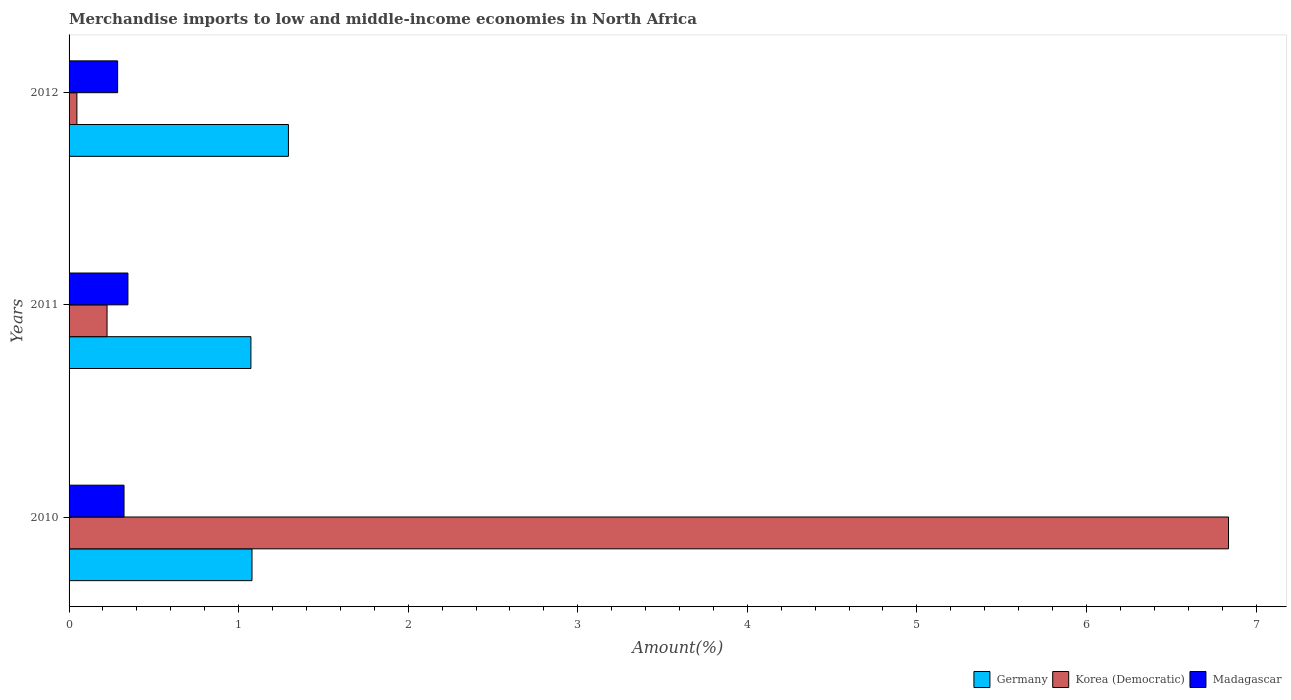How many different coloured bars are there?
Your answer should be very brief. 3. How many groups of bars are there?
Give a very brief answer. 3. How many bars are there on the 2nd tick from the top?
Your answer should be compact. 3. How many bars are there on the 2nd tick from the bottom?
Your answer should be very brief. 3. What is the label of the 1st group of bars from the top?
Offer a very short reply. 2012. What is the percentage of amount earned from merchandise imports in Korea (Democratic) in 2010?
Make the answer very short. 6.84. Across all years, what is the maximum percentage of amount earned from merchandise imports in Madagascar?
Provide a short and direct response. 0.35. Across all years, what is the minimum percentage of amount earned from merchandise imports in Korea (Democratic)?
Keep it short and to the point. 0.05. In which year was the percentage of amount earned from merchandise imports in Korea (Democratic) minimum?
Provide a succinct answer. 2012. What is the total percentage of amount earned from merchandise imports in Germany in the graph?
Your answer should be compact. 3.44. What is the difference between the percentage of amount earned from merchandise imports in Madagascar in 2010 and that in 2012?
Ensure brevity in your answer.  0.04. What is the difference between the percentage of amount earned from merchandise imports in Korea (Democratic) in 2010 and the percentage of amount earned from merchandise imports in Germany in 2012?
Your answer should be compact. 5.54. What is the average percentage of amount earned from merchandise imports in Korea (Democratic) per year?
Make the answer very short. 2.37. In the year 2011, what is the difference between the percentage of amount earned from merchandise imports in Germany and percentage of amount earned from merchandise imports in Korea (Democratic)?
Ensure brevity in your answer.  0.85. In how many years, is the percentage of amount earned from merchandise imports in Germany greater than 4.6 %?
Give a very brief answer. 0. What is the ratio of the percentage of amount earned from merchandise imports in Korea (Democratic) in 2011 to that in 2012?
Offer a very short reply. 4.86. Is the percentage of amount earned from merchandise imports in Korea (Democratic) in 2011 less than that in 2012?
Keep it short and to the point. No. Is the difference between the percentage of amount earned from merchandise imports in Germany in 2010 and 2011 greater than the difference between the percentage of amount earned from merchandise imports in Korea (Democratic) in 2010 and 2011?
Provide a short and direct response. No. What is the difference between the highest and the second highest percentage of amount earned from merchandise imports in Germany?
Provide a short and direct response. 0.21. What is the difference between the highest and the lowest percentage of amount earned from merchandise imports in Korea (Democratic)?
Keep it short and to the point. 6.79. In how many years, is the percentage of amount earned from merchandise imports in Korea (Democratic) greater than the average percentage of amount earned from merchandise imports in Korea (Democratic) taken over all years?
Provide a succinct answer. 1. What does the 2nd bar from the top in 2011 represents?
Offer a terse response. Korea (Democratic). What does the 2nd bar from the bottom in 2012 represents?
Offer a terse response. Korea (Democratic). Is it the case that in every year, the sum of the percentage of amount earned from merchandise imports in Korea (Democratic) and percentage of amount earned from merchandise imports in Madagascar is greater than the percentage of amount earned from merchandise imports in Germany?
Provide a succinct answer. No. What is the difference between two consecutive major ticks on the X-axis?
Offer a very short reply. 1. Are the values on the major ticks of X-axis written in scientific E-notation?
Your answer should be compact. No. How are the legend labels stacked?
Your answer should be compact. Horizontal. What is the title of the graph?
Your answer should be very brief. Merchandise imports to low and middle-income economies in North Africa. Does "Samoa" appear as one of the legend labels in the graph?
Offer a terse response. No. What is the label or title of the X-axis?
Give a very brief answer. Amount(%). What is the Amount(%) of Germany in 2010?
Provide a short and direct response. 1.08. What is the Amount(%) of Korea (Democratic) in 2010?
Ensure brevity in your answer.  6.84. What is the Amount(%) of Madagascar in 2010?
Provide a short and direct response. 0.32. What is the Amount(%) in Germany in 2011?
Provide a succinct answer. 1.07. What is the Amount(%) of Korea (Democratic) in 2011?
Provide a short and direct response. 0.22. What is the Amount(%) of Madagascar in 2011?
Offer a very short reply. 0.35. What is the Amount(%) in Germany in 2012?
Your answer should be very brief. 1.29. What is the Amount(%) in Korea (Democratic) in 2012?
Keep it short and to the point. 0.05. What is the Amount(%) of Madagascar in 2012?
Give a very brief answer. 0.29. Across all years, what is the maximum Amount(%) of Germany?
Provide a succinct answer. 1.29. Across all years, what is the maximum Amount(%) of Korea (Democratic)?
Provide a succinct answer. 6.84. Across all years, what is the maximum Amount(%) in Madagascar?
Your answer should be compact. 0.35. Across all years, what is the minimum Amount(%) in Germany?
Make the answer very short. 1.07. Across all years, what is the minimum Amount(%) of Korea (Democratic)?
Keep it short and to the point. 0.05. Across all years, what is the minimum Amount(%) in Madagascar?
Make the answer very short. 0.29. What is the total Amount(%) in Germany in the graph?
Offer a terse response. 3.44. What is the total Amount(%) of Korea (Democratic) in the graph?
Provide a succinct answer. 7.11. What is the total Amount(%) in Madagascar in the graph?
Your answer should be very brief. 0.96. What is the difference between the Amount(%) of Germany in 2010 and that in 2011?
Offer a very short reply. 0.01. What is the difference between the Amount(%) in Korea (Democratic) in 2010 and that in 2011?
Keep it short and to the point. 6.61. What is the difference between the Amount(%) of Madagascar in 2010 and that in 2011?
Ensure brevity in your answer.  -0.02. What is the difference between the Amount(%) of Germany in 2010 and that in 2012?
Your answer should be compact. -0.21. What is the difference between the Amount(%) in Korea (Democratic) in 2010 and that in 2012?
Your response must be concise. 6.79. What is the difference between the Amount(%) in Madagascar in 2010 and that in 2012?
Offer a terse response. 0.04. What is the difference between the Amount(%) in Germany in 2011 and that in 2012?
Your answer should be very brief. -0.22. What is the difference between the Amount(%) in Korea (Democratic) in 2011 and that in 2012?
Keep it short and to the point. 0.18. What is the difference between the Amount(%) in Madagascar in 2011 and that in 2012?
Your answer should be very brief. 0.06. What is the difference between the Amount(%) of Germany in 2010 and the Amount(%) of Korea (Democratic) in 2011?
Offer a very short reply. 0.85. What is the difference between the Amount(%) of Germany in 2010 and the Amount(%) of Madagascar in 2011?
Provide a short and direct response. 0.73. What is the difference between the Amount(%) of Korea (Democratic) in 2010 and the Amount(%) of Madagascar in 2011?
Offer a very short reply. 6.49. What is the difference between the Amount(%) in Germany in 2010 and the Amount(%) in Korea (Democratic) in 2012?
Offer a very short reply. 1.03. What is the difference between the Amount(%) of Germany in 2010 and the Amount(%) of Madagascar in 2012?
Ensure brevity in your answer.  0.79. What is the difference between the Amount(%) of Korea (Democratic) in 2010 and the Amount(%) of Madagascar in 2012?
Provide a short and direct response. 6.55. What is the difference between the Amount(%) in Germany in 2011 and the Amount(%) in Korea (Democratic) in 2012?
Provide a succinct answer. 1.03. What is the difference between the Amount(%) in Germany in 2011 and the Amount(%) in Madagascar in 2012?
Offer a very short reply. 0.79. What is the difference between the Amount(%) of Korea (Democratic) in 2011 and the Amount(%) of Madagascar in 2012?
Your answer should be very brief. -0.06. What is the average Amount(%) of Germany per year?
Offer a very short reply. 1.15. What is the average Amount(%) in Korea (Democratic) per year?
Give a very brief answer. 2.37. What is the average Amount(%) in Madagascar per year?
Provide a succinct answer. 0.32. In the year 2010, what is the difference between the Amount(%) in Germany and Amount(%) in Korea (Democratic)?
Provide a succinct answer. -5.76. In the year 2010, what is the difference between the Amount(%) in Germany and Amount(%) in Madagascar?
Provide a short and direct response. 0.75. In the year 2010, what is the difference between the Amount(%) in Korea (Democratic) and Amount(%) in Madagascar?
Your response must be concise. 6.51. In the year 2011, what is the difference between the Amount(%) of Germany and Amount(%) of Korea (Democratic)?
Make the answer very short. 0.85. In the year 2011, what is the difference between the Amount(%) in Germany and Amount(%) in Madagascar?
Keep it short and to the point. 0.73. In the year 2011, what is the difference between the Amount(%) in Korea (Democratic) and Amount(%) in Madagascar?
Ensure brevity in your answer.  -0.12. In the year 2012, what is the difference between the Amount(%) of Germany and Amount(%) of Korea (Democratic)?
Your answer should be compact. 1.25. In the year 2012, what is the difference between the Amount(%) of Germany and Amount(%) of Madagascar?
Ensure brevity in your answer.  1.01. In the year 2012, what is the difference between the Amount(%) of Korea (Democratic) and Amount(%) of Madagascar?
Offer a very short reply. -0.24. What is the ratio of the Amount(%) of Germany in 2010 to that in 2011?
Your answer should be compact. 1.01. What is the ratio of the Amount(%) in Korea (Democratic) in 2010 to that in 2011?
Provide a succinct answer. 30.53. What is the ratio of the Amount(%) of Madagascar in 2010 to that in 2011?
Offer a very short reply. 0.93. What is the ratio of the Amount(%) in Germany in 2010 to that in 2012?
Your answer should be very brief. 0.83. What is the ratio of the Amount(%) of Korea (Democratic) in 2010 to that in 2012?
Ensure brevity in your answer.  148.27. What is the ratio of the Amount(%) of Madagascar in 2010 to that in 2012?
Keep it short and to the point. 1.13. What is the ratio of the Amount(%) in Germany in 2011 to that in 2012?
Your answer should be very brief. 0.83. What is the ratio of the Amount(%) of Korea (Democratic) in 2011 to that in 2012?
Offer a very short reply. 4.86. What is the ratio of the Amount(%) in Madagascar in 2011 to that in 2012?
Your answer should be very brief. 1.21. What is the difference between the highest and the second highest Amount(%) of Germany?
Offer a very short reply. 0.21. What is the difference between the highest and the second highest Amount(%) of Korea (Democratic)?
Ensure brevity in your answer.  6.61. What is the difference between the highest and the second highest Amount(%) of Madagascar?
Your response must be concise. 0.02. What is the difference between the highest and the lowest Amount(%) in Germany?
Keep it short and to the point. 0.22. What is the difference between the highest and the lowest Amount(%) in Korea (Democratic)?
Make the answer very short. 6.79. What is the difference between the highest and the lowest Amount(%) in Madagascar?
Ensure brevity in your answer.  0.06. 